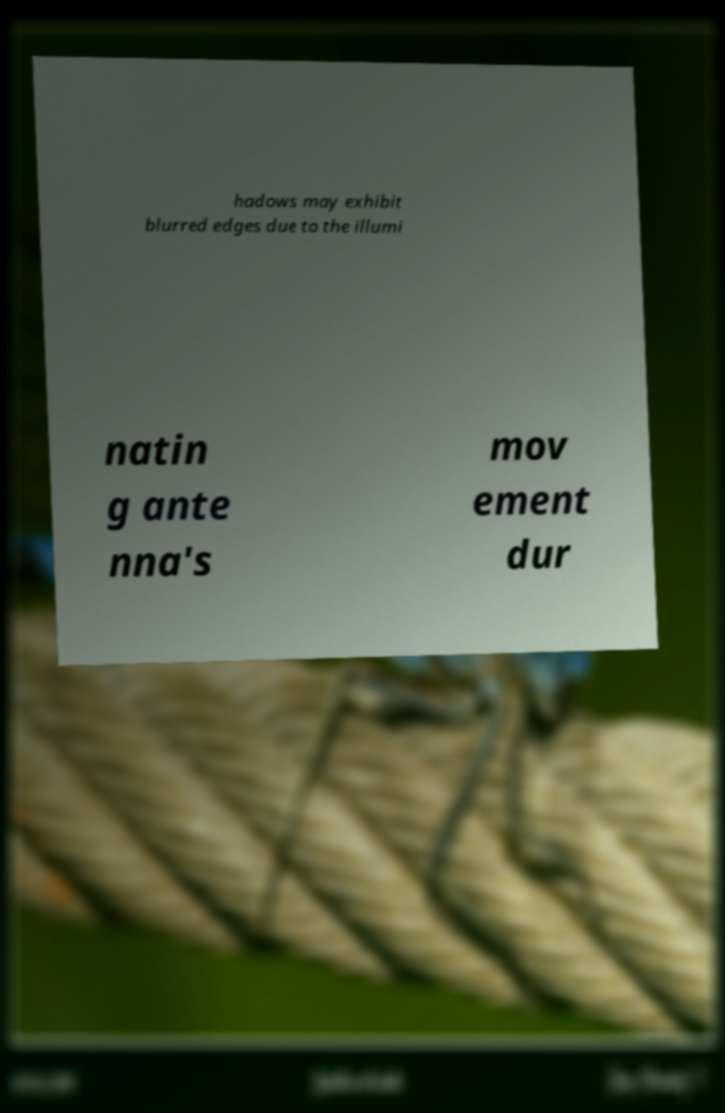There's text embedded in this image that I need extracted. Can you transcribe it verbatim? hadows may exhibit blurred edges due to the illumi natin g ante nna's mov ement dur 